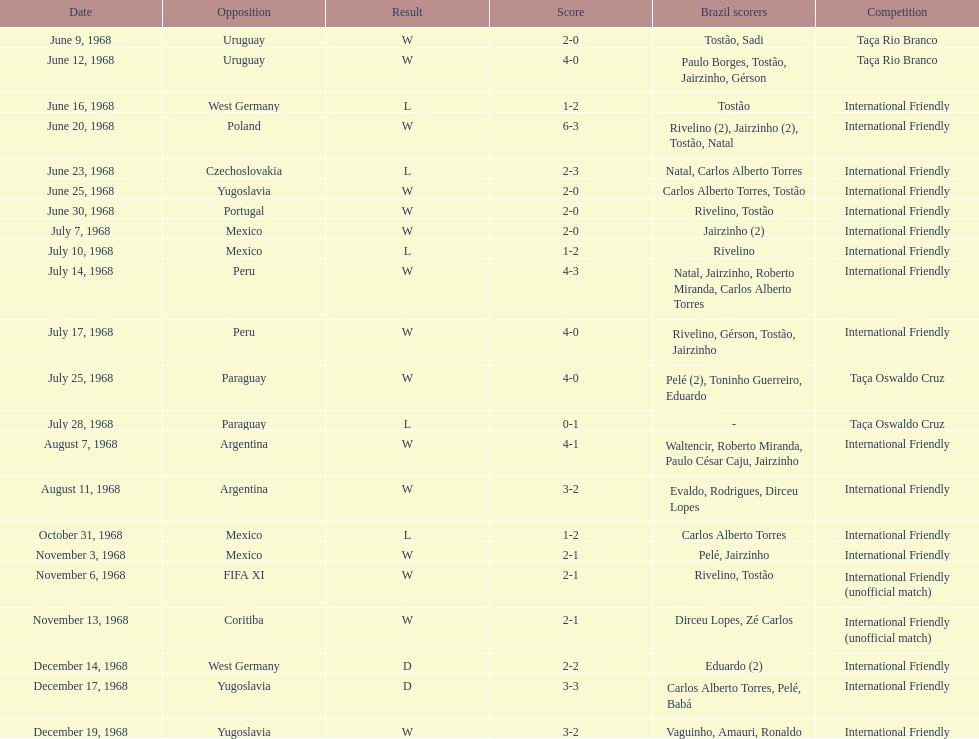What year has the highest scoring game? 1968. 